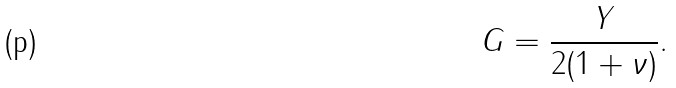<formula> <loc_0><loc_0><loc_500><loc_500>G = \frac { Y } { 2 ( 1 + \nu ) } .</formula> 